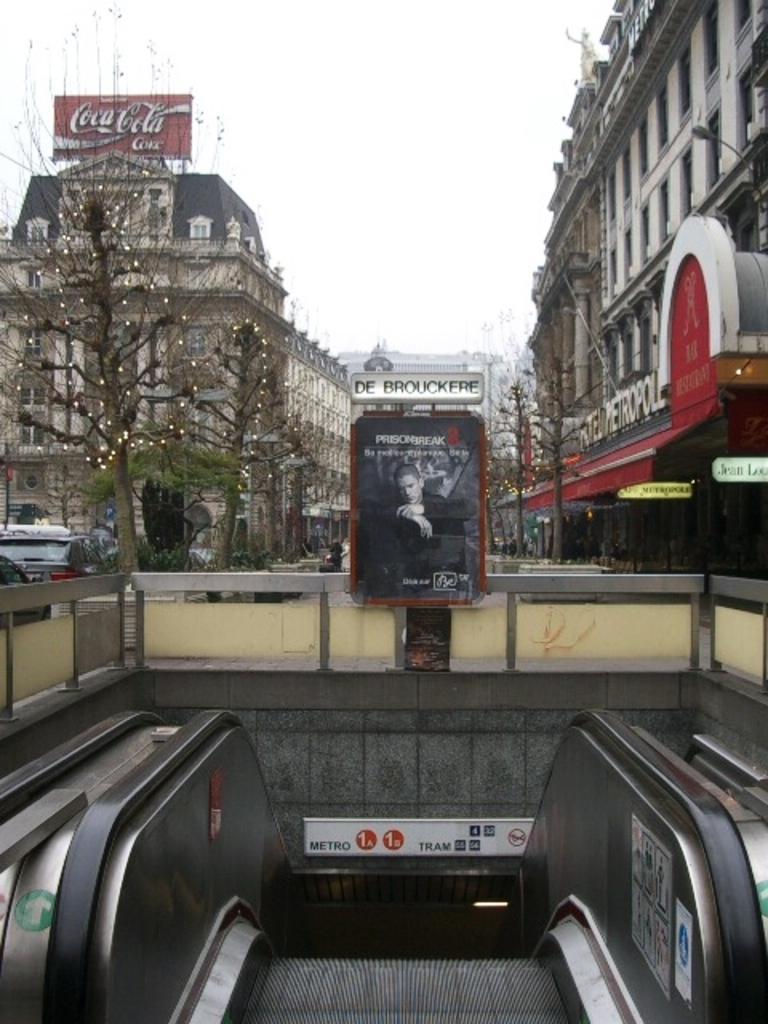Please provide a concise description of this image. In this picture we can see an escalator. There is a board. We can see some vehicles on the road. There are few trees and buildings in the background. 